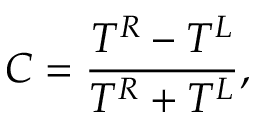Convert formula to latex. <formula><loc_0><loc_0><loc_500><loc_500>C = \frac { T ^ { R } - T ^ { L } } { T ^ { R } + T ^ { L } } ,</formula> 